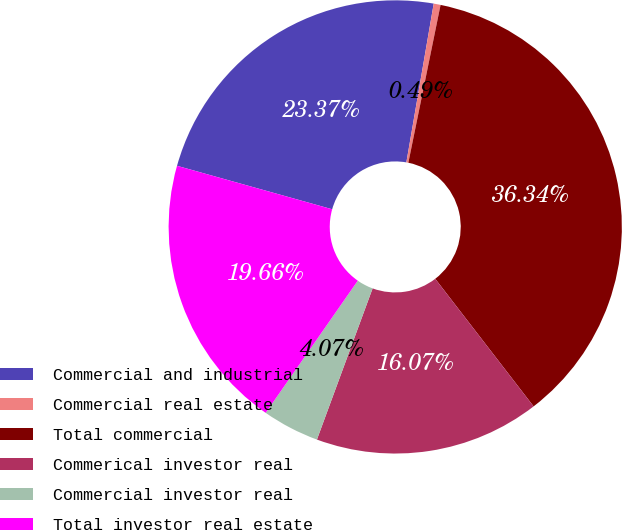<chart> <loc_0><loc_0><loc_500><loc_500><pie_chart><fcel>Commercial and industrial<fcel>Commercial real estate<fcel>Total commercial<fcel>Commerical investor real<fcel>Commercial investor real<fcel>Total investor real estate<nl><fcel>23.37%<fcel>0.49%<fcel>36.34%<fcel>16.07%<fcel>4.07%<fcel>19.66%<nl></chart> 